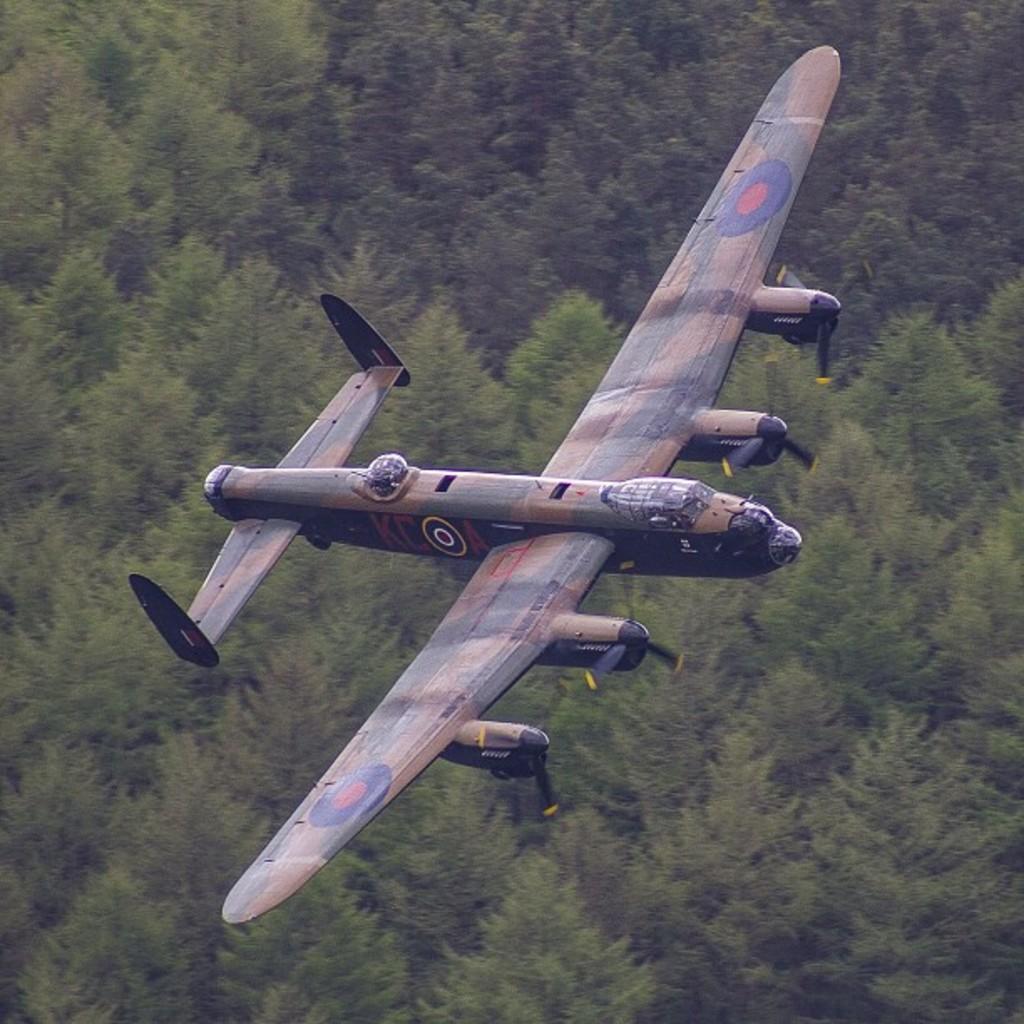Could you give a brief overview of what you see in this image? There is an aircraft flying in the air. Below this, there are trees. which are having green color leaves. 